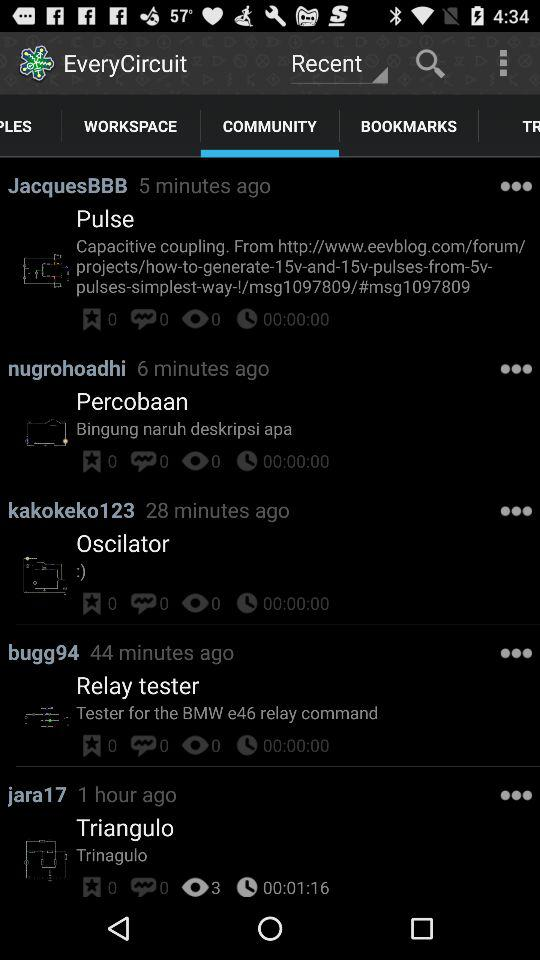Which option is selected for "EveryCircuit"? The selected options are "Recent" and "COMMUNITY". 